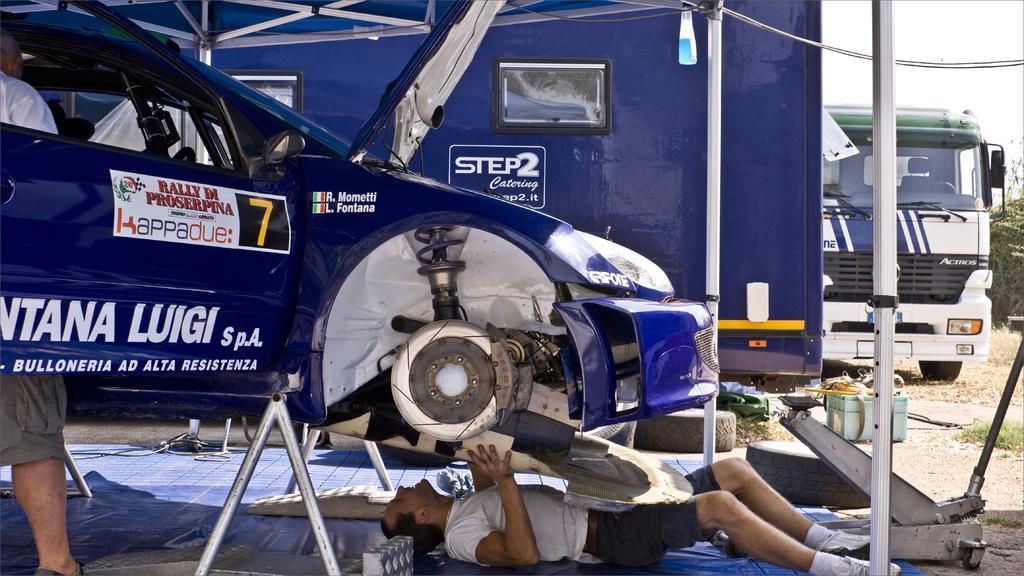Describe this image in one or two sentences. There is a man laying and holding an object and we can see car,behind this car door there is a man standing and we can see wires. In the background we can see vehicle,grass,trees and sky. 